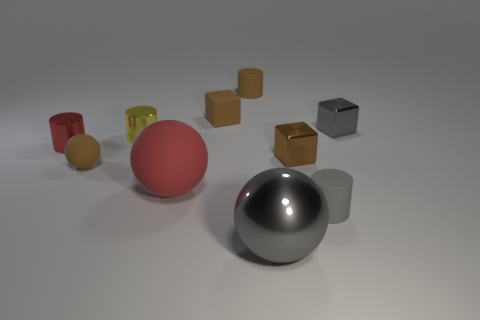There is a cylinder that is the same color as the large metallic thing; what material is it?
Give a very brief answer. Rubber. What number of small cylinders have the same color as the tiny matte cube?
Provide a short and direct response. 1. There is a tiny rubber sphere; is it the same color as the small metallic object in front of the small red metal cylinder?
Provide a succinct answer. Yes. What is the size of the metal block that is the same color as the small rubber block?
Provide a short and direct response. Small. Is the tiny rubber block the same color as the tiny ball?
Make the answer very short. Yes. Are there fewer brown things on the right side of the brown ball than tiny brown metal cylinders?
Your answer should be very brief. No. There is a rubber sphere on the right side of the tiny yellow metallic cylinder; what color is it?
Make the answer very short. Red. What is the shape of the large matte thing?
Ensure brevity in your answer.  Sphere. Is there a tiny object behind the small metal cube that is in front of the shiny cylinder right of the brown ball?
Offer a terse response. Yes. There is a sphere that is right of the small cylinder behind the brown block that is left of the large gray metallic sphere; what is its color?
Your answer should be compact. Gray. 